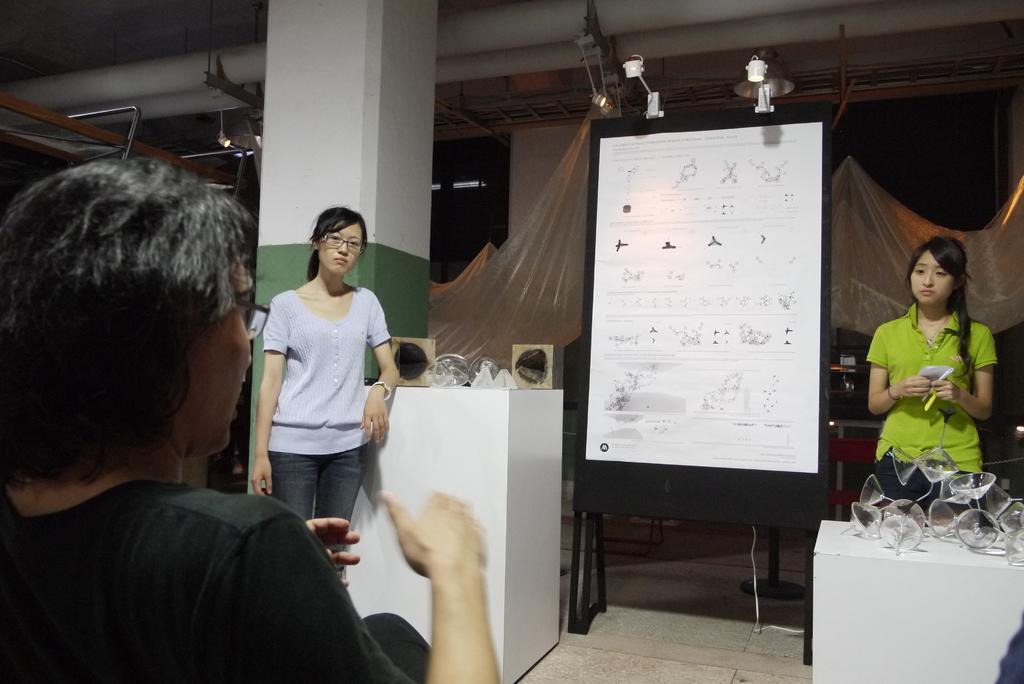In one or two sentences, can you explain what this image depicts? In the foreground of this image, there is a persons sitting. In the background, there is a board, few objects on the tables, two women standing, a pillar, ceiling, lights, cover sheets and the floor. 